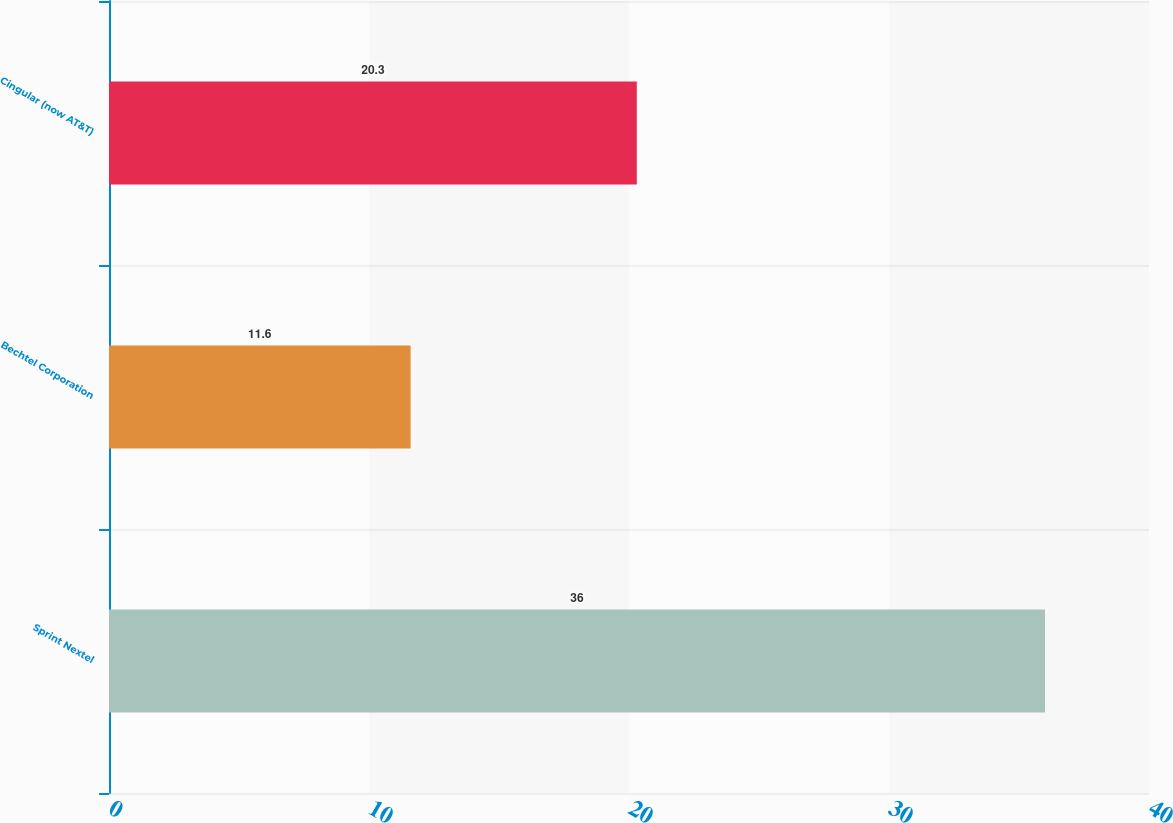<chart> <loc_0><loc_0><loc_500><loc_500><bar_chart><fcel>Sprint Nextel<fcel>Bechtel Corporation<fcel>Cingular (now AT&T)<nl><fcel>36<fcel>11.6<fcel>20.3<nl></chart> 